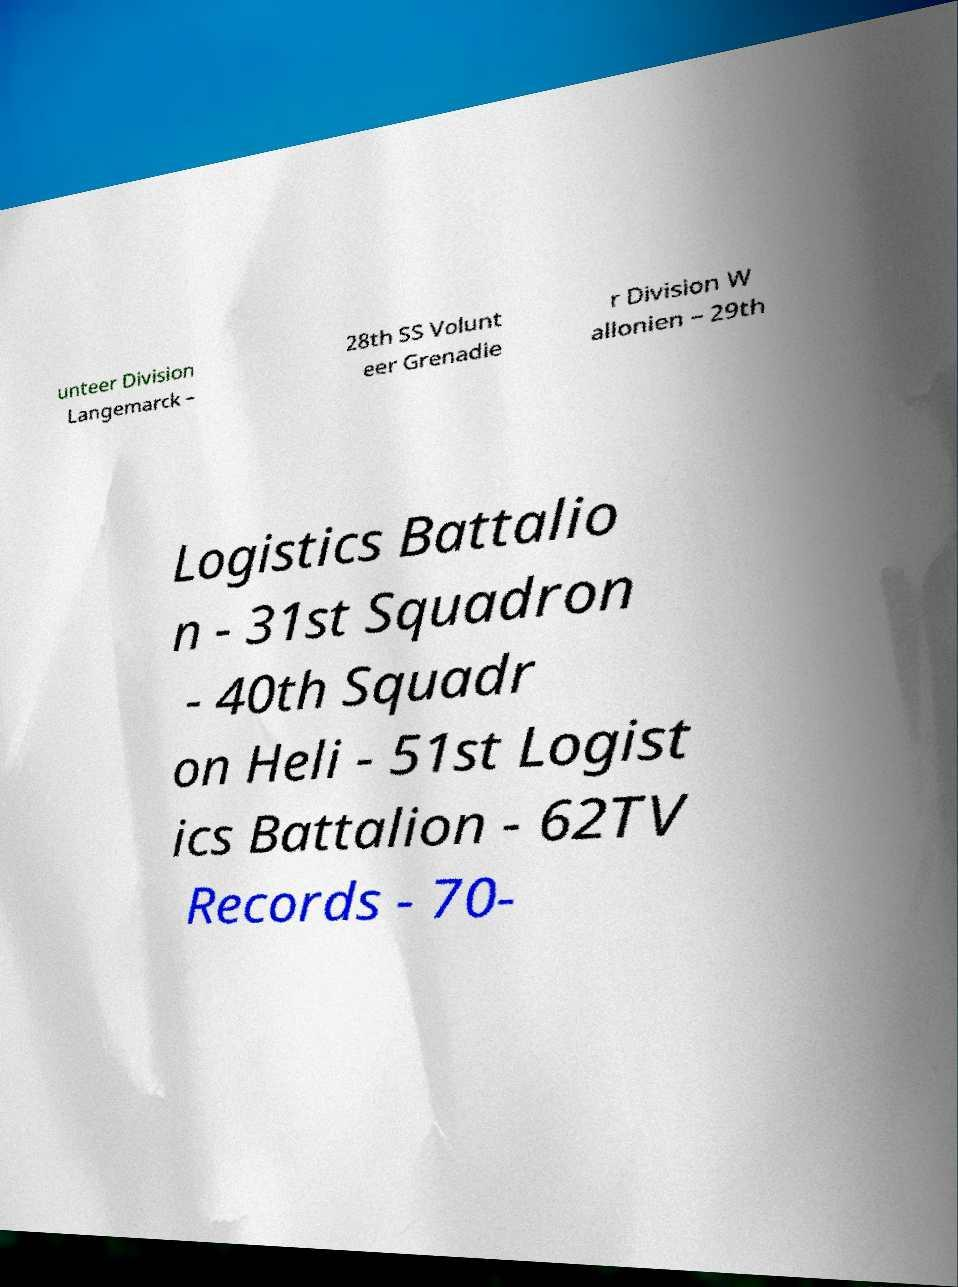I need the written content from this picture converted into text. Can you do that? unteer Division Langemarck – 28th SS Volunt eer Grenadie r Division W allonien – 29th Logistics Battalio n - 31st Squadron - 40th Squadr on Heli - 51st Logist ics Battalion - 62TV Records - 70- 